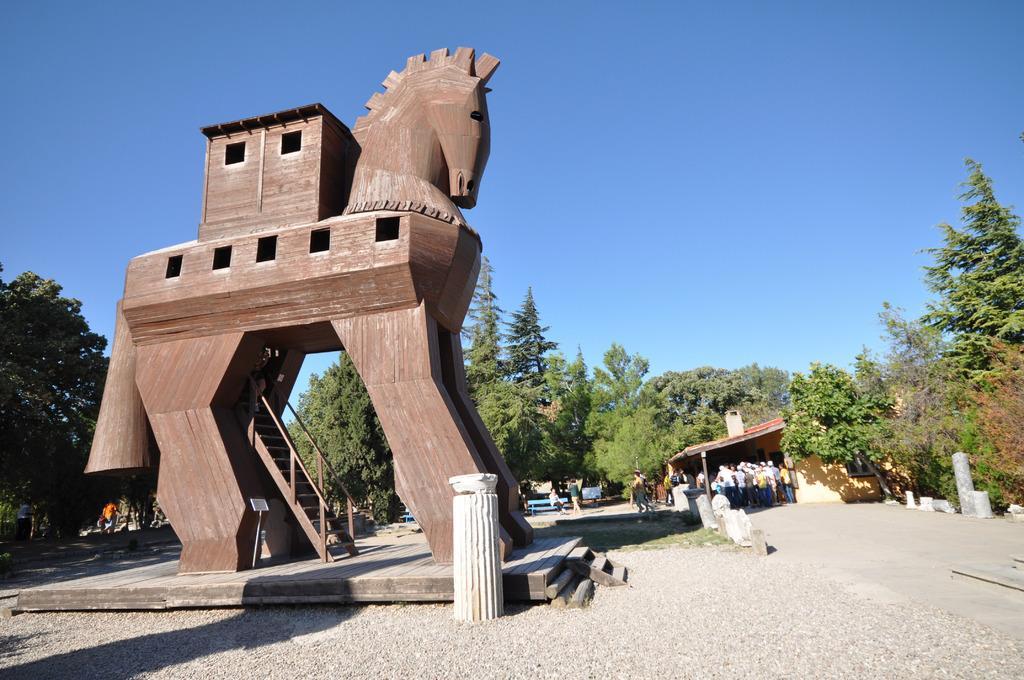In one or two sentences, can you explain what this image depicts? In this image we can see a wooden sculpture and stairs to it, barrier poles, persons standing on the ground, shed, benches and persons sitting on them, trees and sky in the background. 